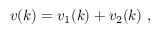Convert formula to latex. <formula><loc_0><loc_0><loc_500><loc_500>v ( k ) = v _ { 1 } ( k ) + v _ { 2 } ( k ) \ ,</formula> 